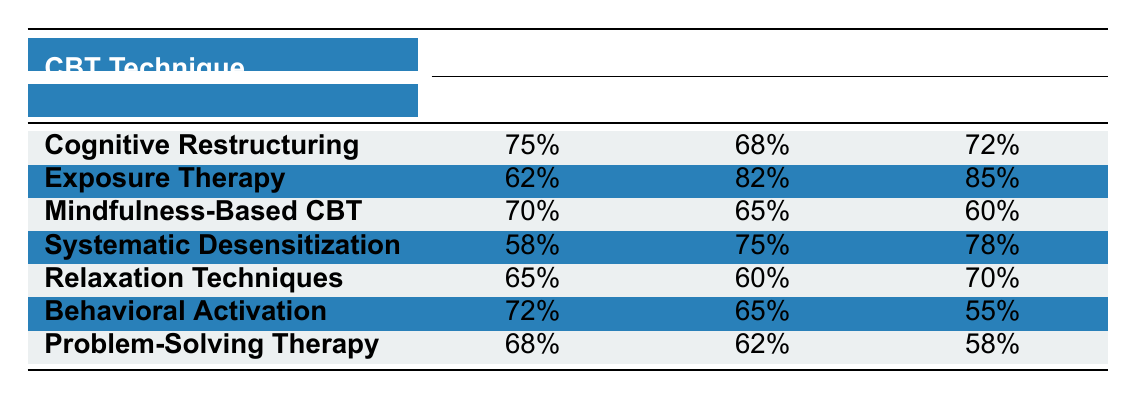What is the effectiveness rate of Cognitive Restructuring for GAD? The table shows the effectiveness rates for various CBT techniques across different anxiety disorders. For Cognitive Restructuring, the value in the GAD column is listed as 75%.
Answer: 75% Which technique has the highest effectiveness rate for Social Anxiety? The table indicates the effectiveness rates for each technique specifically for Social Anxiety. By comparing the values, Exposure Therapy has the highest rate at 82%.
Answer: Exposure Therapy Is the effectiveness rate for Mindfulness-Based CBT higher for GAD or Panic Disorder? The table lists the effectiveness rates for Mindfulness-Based CBT as 70% for GAD and 60% for Panic Disorder. Since 70% is greater than 60%, it is higher for GAD.
Answer: GAD What is the average effectiveness rate for the techniques on Panic Disorder? To find the average, we sum the effectiveness rates for Panic Disorder: 72% + 85% + 60% + 78% + 70% + 55% + 58% = 478%. There are 7 techniques, so the average is 478% / 7 = 68.29%.
Answer: 68.29% Does Behavioral Activation have a higher effectiveness rate than Relaxation Techniques for Social Anxiety? The effectiveness rate for Behavioral Activation for Social Anxiety is 65%, while Relaxation Techniques has an effectiveness rate of 60%. Since 65% is greater than 60%, the statement is true.
Answer: Yes What is the difference in effectiveness rates for Exposure Therapy between Social Anxiety and Panic Disorder? For Exposure Therapy, the rate for Social Anxiety is 82% and for Panic Disorder is 85%. The difference can be calculated as 85% - 82% = 3%.
Answer: 3% Which technique has the lowest effectiveness rate for GAD? By reviewing the GAD effectiveness rates, Systematic Desensitization has the lowest value at 58%, compared to the other techniques listed.
Answer: Systematic Desensitization Is it true that Problem-Solving Therapy has a higher effectiveness rate for GAD than for Social Anxiety? Problem-Solving Therapy has an effectiveness rate of 68% for GAD and 62% for Social Anxiety. Since 68% is greater than 62%, the statement is true.
Answer: Yes What is the total effectiveness rate for Exposure Therapy and Relaxation Techniques for Panic Disorder? The effectiveness rate for Exposure Therapy for Panic Disorder is 85% and for Relaxation Techniques, it is 70%. Adding these gives a total of 85% + 70% = 155%.
Answer: 155% 